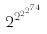<formula> <loc_0><loc_0><loc_500><loc_500>2 ^ { 2 ^ { 2 ^ { 2 ^ { 7 4 } } } }</formula> 